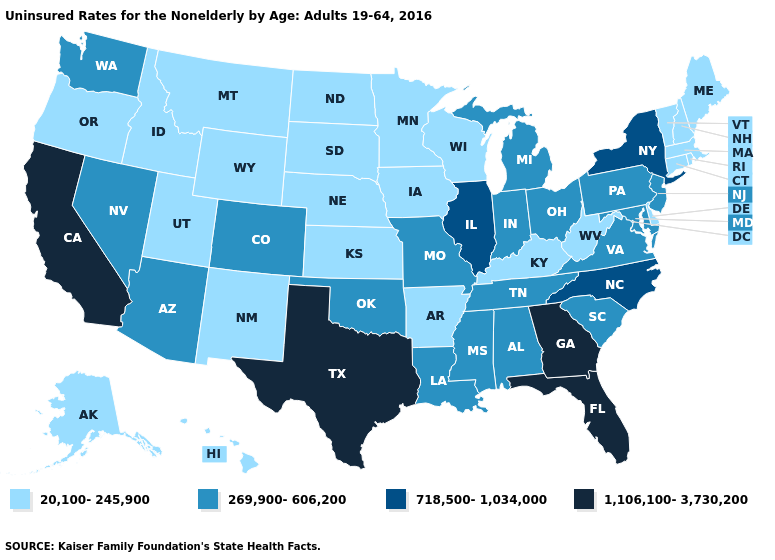What is the value of Nevada?
Quick response, please. 269,900-606,200. Which states have the highest value in the USA?
Keep it brief. California, Florida, Georgia, Texas. Does Illinois have a lower value than Georgia?
Write a very short answer. Yes. Does Texas have the highest value in the USA?
Keep it brief. Yes. Among the states that border Tennessee , does Arkansas have the lowest value?
Concise answer only. Yes. Among the states that border Alabama , does Florida have the lowest value?
Write a very short answer. No. Which states hav the highest value in the West?
Be succinct. California. What is the highest value in the USA?
Give a very brief answer. 1,106,100-3,730,200. Does Kansas have the same value as Oklahoma?
Answer briefly. No. What is the highest value in the USA?
Give a very brief answer. 1,106,100-3,730,200. Which states have the lowest value in the Northeast?
Answer briefly. Connecticut, Maine, Massachusetts, New Hampshire, Rhode Island, Vermont. Among the states that border Kansas , which have the lowest value?
Concise answer only. Nebraska. Among the states that border Nebraska , which have the highest value?
Keep it brief. Colorado, Missouri. What is the value of New Hampshire?
Write a very short answer. 20,100-245,900. What is the highest value in the USA?
Short answer required. 1,106,100-3,730,200. 